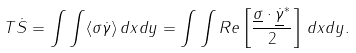Convert formula to latex. <formula><loc_0><loc_0><loc_500><loc_500>T \dot { S } = \int \int \langle \sigma \dot { \gamma } \rangle \, d x d y = \int \int R e \left [ \frac { \underline { \sigma } \cdot \underline { \dot { \gamma } } ^ { * } } { 2 } \right ] \, d x d y .</formula> 